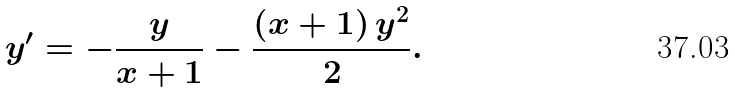<formula> <loc_0><loc_0><loc_500><loc_500>y ^ { \prime } = - \frac { y } { x + 1 } - \frac { \left ( x + 1 \right ) y ^ { 2 } } { 2 } .</formula> 